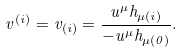<formula> <loc_0><loc_0><loc_500><loc_500>v ^ { ( i ) } = v _ { ( i ) } = \frac { u ^ { \mu } h _ { \mu ( i ) } } { - u ^ { \mu } h _ { \mu ( 0 ) } } .</formula> 